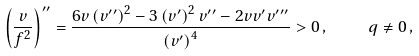Convert formula to latex. <formula><loc_0><loc_0><loc_500><loc_500>\left ( \frac { v } { f ^ { 2 } } \right ) ^ { \prime \prime } = \frac { 6 v \left ( v ^ { \prime \prime } \right ) ^ { 2 } - 3 \left ( v ^ { \prime } \right ) ^ { 2 } v ^ { \prime \prime } - 2 v v ^ { \prime } v ^ { \prime \prime \prime } } { \left ( v ^ { \prime } \right ) ^ { 4 } } > 0 \, , \quad q \neq 0 \, ,</formula> 